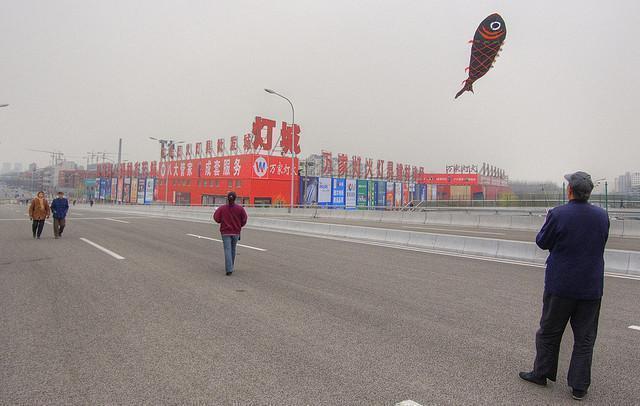What is the giant fish in the air?
Select the correct answer and articulate reasoning with the following format: 'Answer: answer
Rationale: rationale.'
Options: Blimp, balloon, kite, sculpture. Answer: kite.
Rationale: The giant fish is made of a light weight material connected to string. 